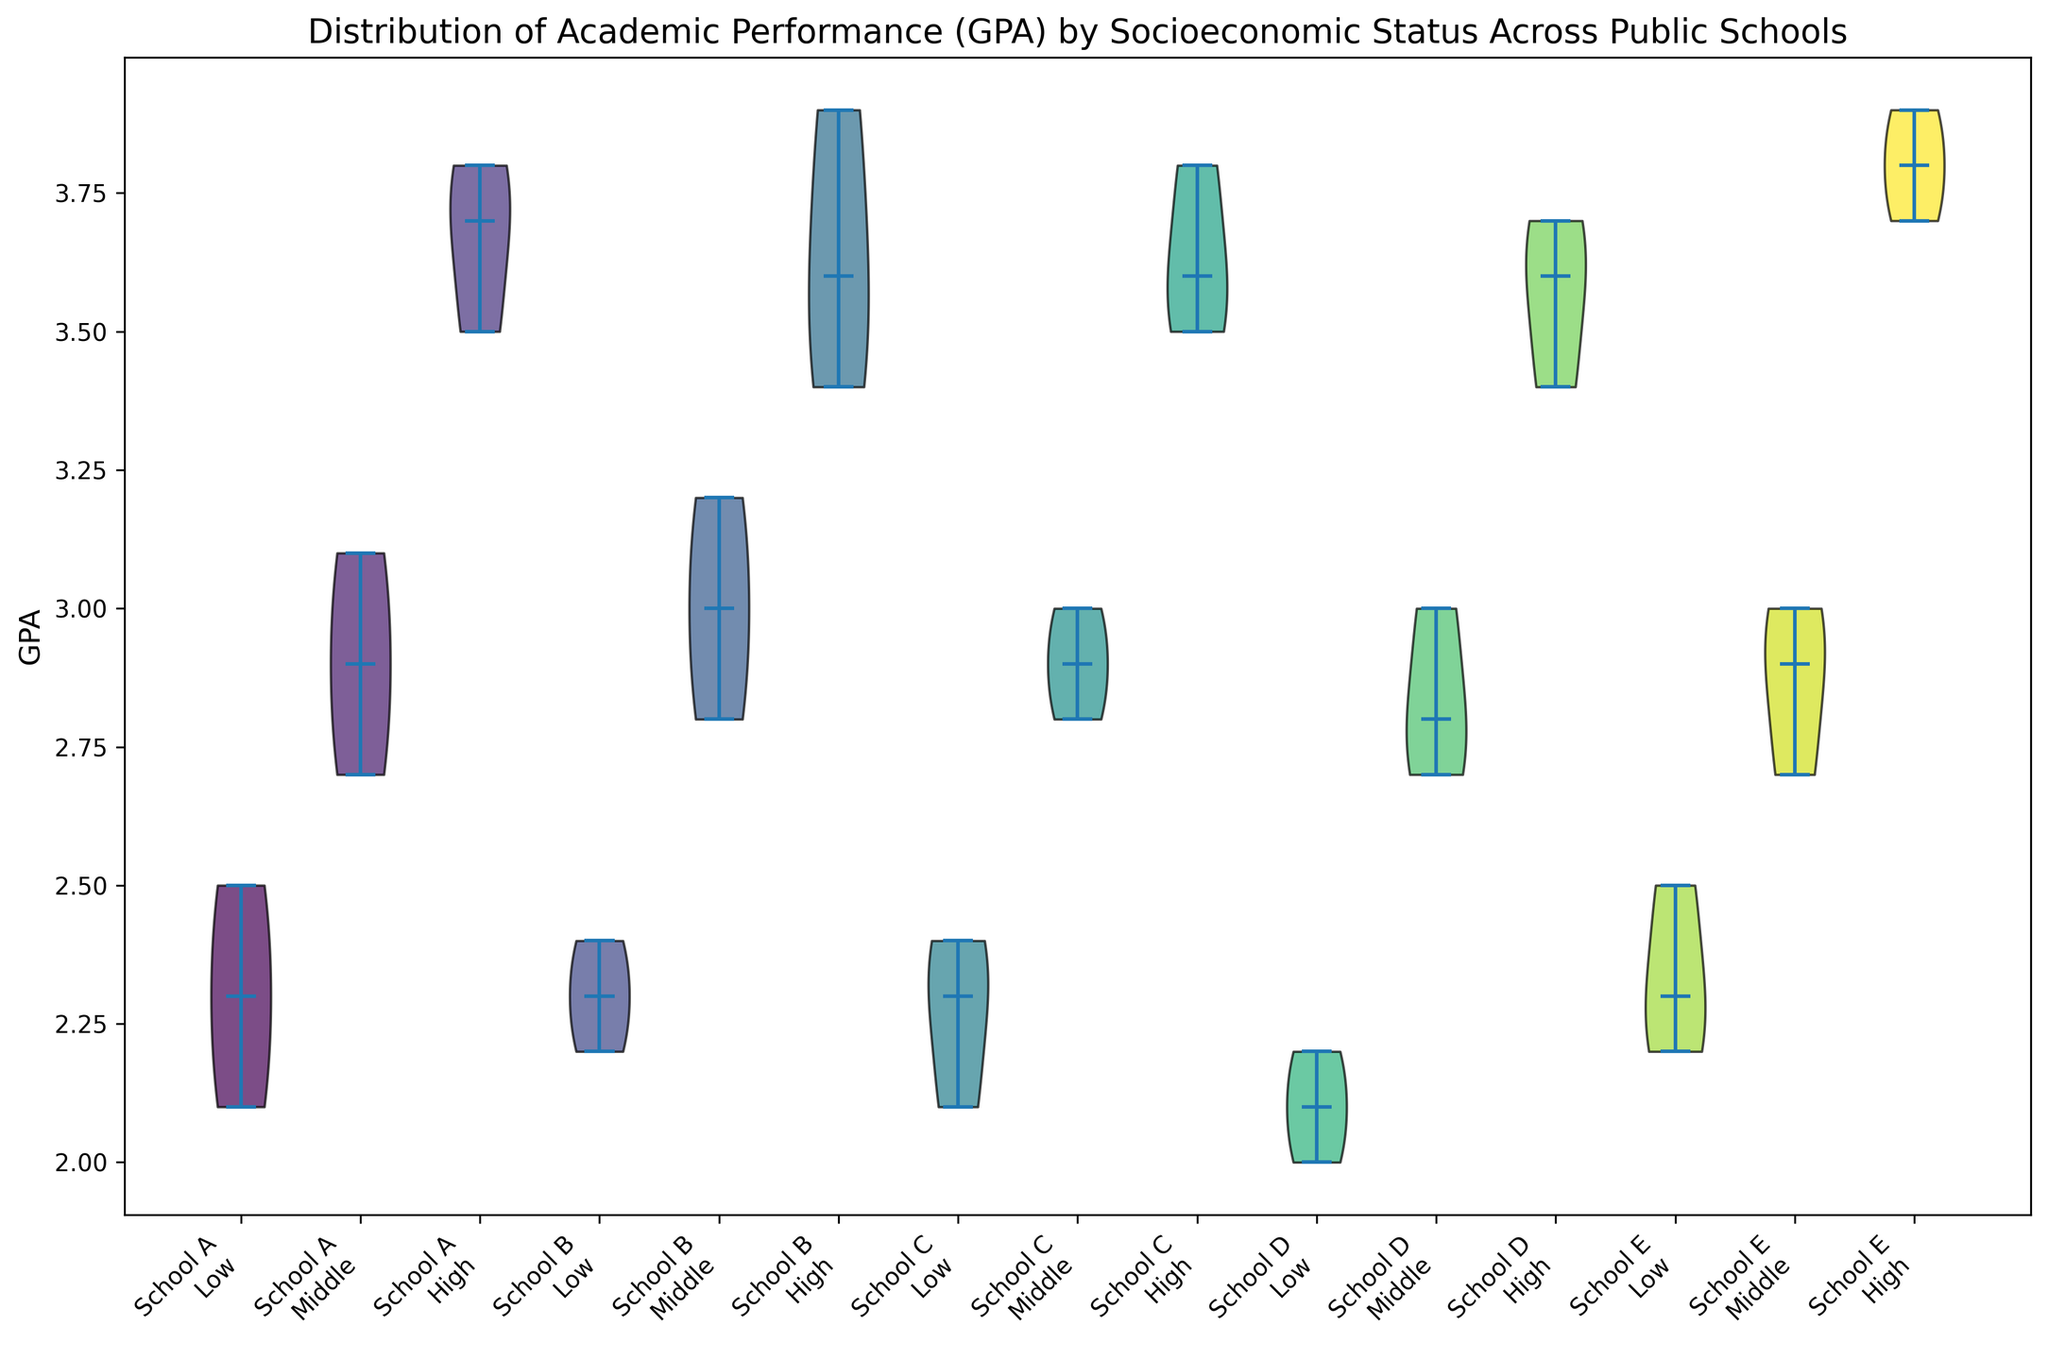What is the overall trend in GPA distribution among different SES groups across the schools? To determine the overall trend, observe the median GPA lines within each violin plot for low, middle, and high SES across different schools. Generally, the median GPA increases from low SES to high SES, indicating that higher SES groups tend to have higher GPAs.
Answer: Higher SES groups have higher GPAs Which high-SES group has the highest median GPA among all schools? Look for the thick black horizontal line representing the median value in the violin plots for the high SES group across all schools. The highest position of this line in the high SES groups indicates the highest median GPA. In this case, School E's high SES group has the highest median GPA.
Answer: School E How does the GPA distribution for low SES in School A compare with high SES in School B? Compare the height and spread of the violins for low SES in School A and high SES in School B. The median GPA (black line) and the density of data points (width of the violin) should be considered. School A's low SES group has a lower median and narrower distribution compared to the wider and higher median in School B's high SES group.
Answer: School B's high SES is higher and more spread out What is the range of GPAs for the middle SES group in School C? The range can be observed by looking at the vertical extent of the middle SES violin plot for School C. Identify the lowest and highest points of the violin. For School C, the middle SES group's GPAs range from around 2.8 to 3.0.
Answer: 2.8 to 3.0 Which school shows the smallest variation in GPA for the low SES group? Variation can be inferred from the width of the violin plots for the low SES groups. The narrower the violin, the smaller the GPA variation. School D has the narrowest low SES violin plot, indicating the smallest variation in GPA.
Answer: School D Is there any school where the middle SES group's median GPA is higher than the high SES group's median GPA? Compare the median lines of the middle and high SES groups within each school. If any middle SES median line is above the high SES median line, that condition is met. In this case, no schools show a middle SES median GPA higher than the high SES median GPA.
Answer: No Which SES group in School D has the highest median GPA? Identify the median GPA by looking at the thick black horizontal line within the violin plots for School D. The high SES group's median line is the highest among the three SES groups in School D.
Answer: High SES What SES group has the widest GPA distribution in School A? The width of the violin plot indicates the distribution; the wider it is, the more varied the data. Comparing the violins for School A, the high SES group has the widest distribution.
Answer: High SES How similar is the GPA distribution for high SES between School C and School D? Analyze the shape, height, and width of the high SES violin plots for both School C and School D. The distributions are similar in terms of spread and median, though School D shows slightly more density around the median.
Answer: Similar but School D is slightly denser 